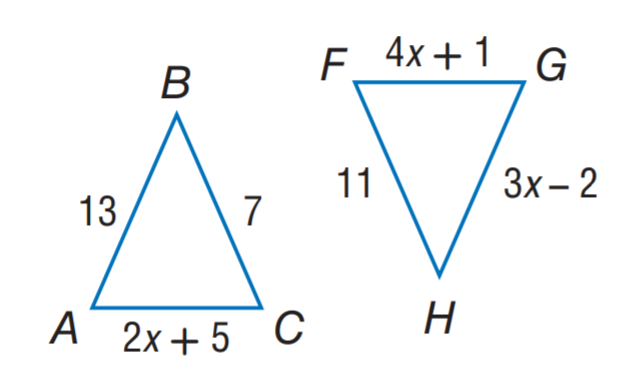Question: \triangle A B C \cong \triangle F G H. Find x.
Choices:
A. 2
B. 3
C. 7
D. 13
Answer with the letter. Answer: B 